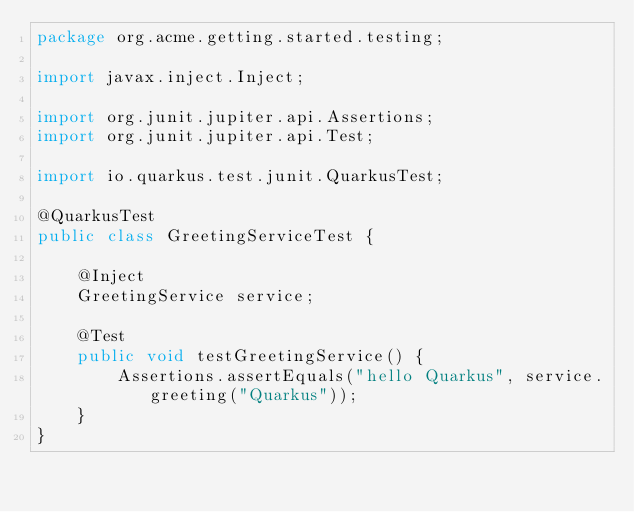<code> <loc_0><loc_0><loc_500><loc_500><_Java_>package org.acme.getting.started.testing;

import javax.inject.Inject;

import org.junit.jupiter.api.Assertions;
import org.junit.jupiter.api.Test;

import io.quarkus.test.junit.QuarkusTest;

@QuarkusTest
public class GreetingServiceTest {

    @Inject
    GreetingService service;

    @Test
    public void testGreetingService() {
        Assertions.assertEquals("hello Quarkus", service.greeting("Quarkus"));
    }
}
</code> 